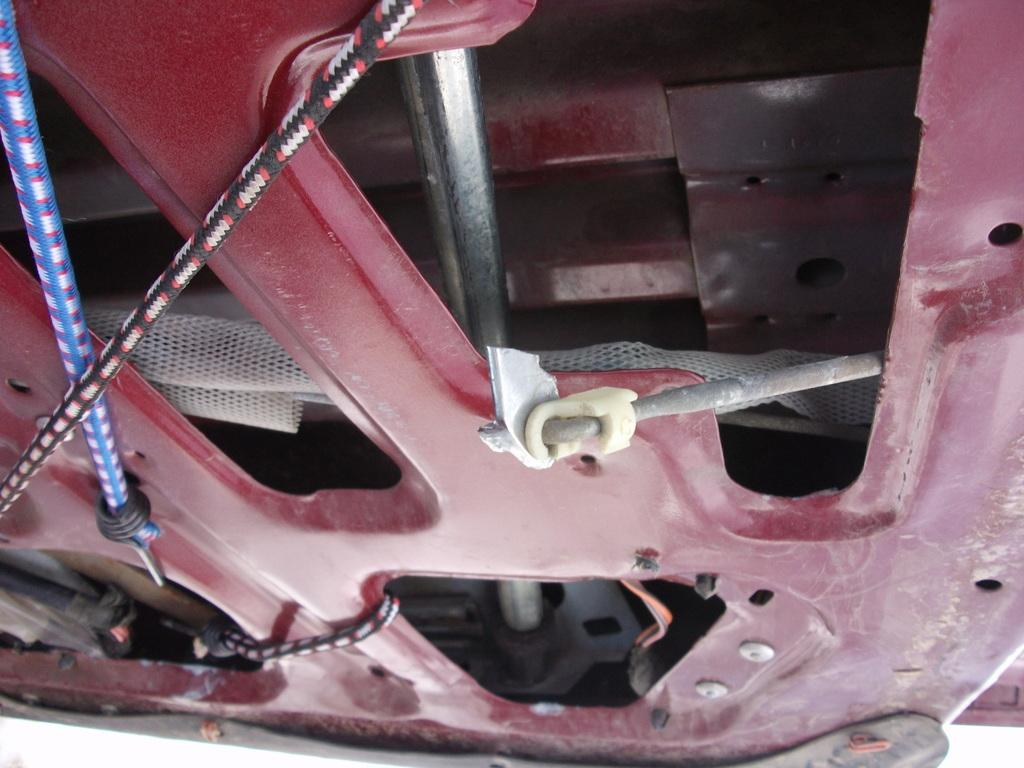What type of clothing item is present in the image? There is a bonnet in the image. How does the bonnet help reduce friction in the image? The bonnet does not have any direct impact on friction in the image, as it is a clothing item and not a mechanical component. 